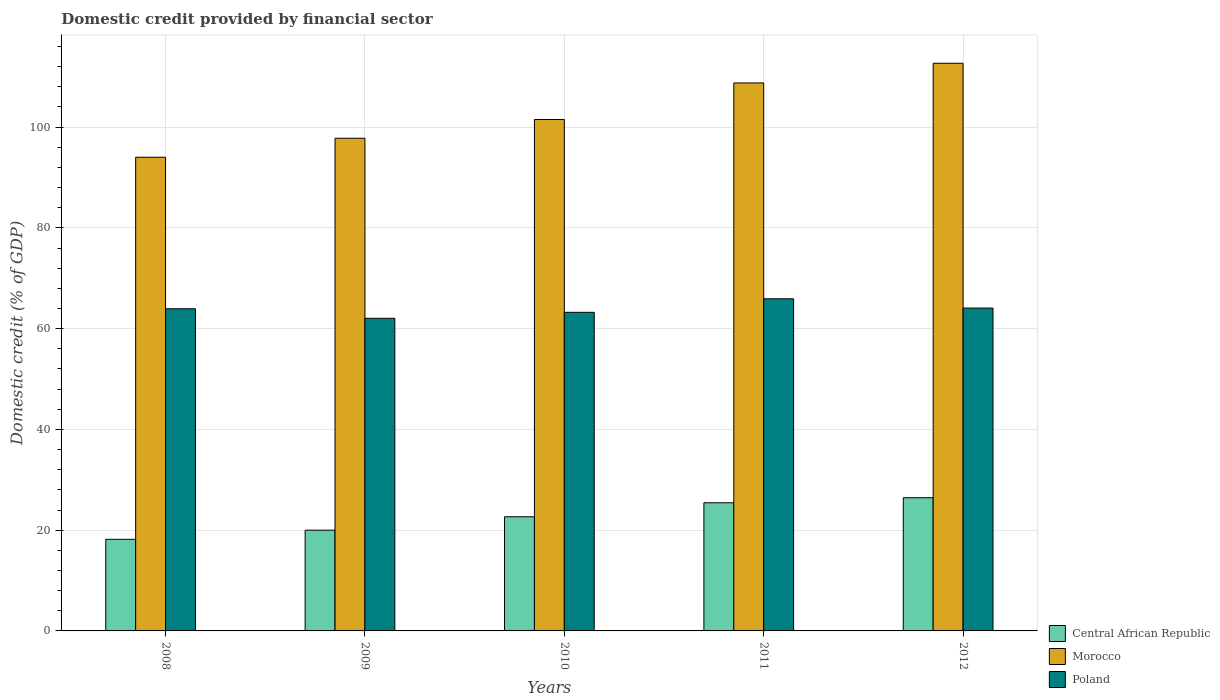Are the number of bars on each tick of the X-axis equal?
Provide a short and direct response. Yes. How many bars are there on the 1st tick from the left?
Offer a very short reply. 3. How many bars are there on the 3rd tick from the right?
Give a very brief answer. 3. What is the label of the 3rd group of bars from the left?
Provide a succinct answer. 2010. What is the domestic credit in Central African Republic in 2011?
Give a very brief answer. 25.44. Across all years, what is the maximum domestic credit in Poland?
Keep it short and to the point. 65.92. Across all years, what is the minimum domestic credit in Poland?
Ensure brevity in your answer.  62.05. In which year was the domestic credit in Morocco maximum?
Make the answer very short. 2012. In which year was the domestic credit in Morocco minimum?
Offer a terse response. 2008. What is the total domestic credit in Morocco in the graph?
Keep it short and to the point. 514.77. What is the difference between the domestic credit in Central African Republic in 2008 and that in 2011?
Offer a very short reply. -7.25. What is the difference between the domestic credit in Poland in 2011 and the domestic credit in Central African Republic in 2009?
Keep it short and to the point. 45.93. What is the average domestic credit in Morocco per year?
Provide a short and direct response. 102.95. In the year 2009, what is the difference between the domestic credit in Poland and domestic credit in Central African Republic?
Offer a very short reply. 42.05. What is the ratio of the domestic credit in Morocco in 2010 to that in 2011?
Keep it short and to the point. 0.93. Is the domestic credit in Morocco in 2008 less than that in 2011?
Ensure brevity in your answer.  Yes. Is the difference between the domestic credit in Poland in 2008 and 2011 greater than the difference between the domestic credit in Central African Republic in 2008 and 2011?
Your answer should be compact. Yes. What is the difference between the highest and the second highest domestic credit in Poland?
Give a very brief answer. 1.84. What is the difference between the highest and the lowest domestic credit in Morocco?
Your answer should be very brief. 18.65. In how many years, is the domestic credit in Poland greater than the average domestic credit in Poland taken over all years?
Your answer should be very brief. 3. What does the 1st bar from the left in 2012 represents?
Your response must be concise. Central African Republic. Is it the case that in every year, the sum of the domestic credit in Central African Republic and domestic credit in Morocco is greater than the domestic credit in Poland?
Ensure brevity in your answer.  Yes. How many bars are there?
Provide a succinct answer. 15. Are all the bars in the graph horizontal?
Make the answer very short. No. How many years are there in the graph?
Your answer should be very brief. 5. What is the difference between two consecutive major ticks on the Y-axis?
Your answer should be compact. 20. Are the values on the major ticks of Y-axis written in scientific E-notation?
Keep it short and to the point. No. Does the graph contain grids?
Your answer should be very brief. Yes. Where does the legend appear in the graph?
Ensure brevity in your answer.  Bottom right. How many legend labels are there?
Your answer should be very brief. 3. What is the title of the graph?
Your answer should be compact. Domestic credit provided by financial sector. What is the label or title of the X-axis?
Give a very brief answer. Years. What is the label or title of the Y-axis?
Keep it short and to the point. Domestic credit (% of GDP). What is the Domestic credit (% of GDP) in Central African Republic in 2008?
Your answer should be compact. 18.18. What is the Domestic credit (% of GDP) of Morocco in 2008?
Offer a terse response. 94.02. What is the Domestic credit (% of GDP) of Poland in 2008?
Your answer should be very brief. 63.95. What is the Domestic credit (% of GDP) in Central African Republic in 2009?
Make the answer very short. 20. What is the Domestic credit (% of GDP) of Morocco in 2009?
Give a very brief answer. 97.79. What is the Domestic credit (% of GDP) of Poland in 2009?
Provide a short and direct response. 62.05. What is the Domestic credit (% of GDP) in Central African Republic in 2010?
Give a very brief answer. 22.66. What is the Domestic credit (% of GDP) in Morocco in 2010?
Keep it short and to the point. 101.51. What is the Domestic credit (% of GDP) of Poland in 2010?
Keep it short and to the point. 63.24. What is the Domestic credit (% of GDP) in Central African Republic in 2011?
Offer a terse response. 25.44. What is the Domestic credit (% of GDP) in Morocco in 2011?
Provide a short and direct response. 108.77. What is the Domestic credit (% of GDP) in Poland in 2011?
Your response must be concise. 65.92. What is the Domestic credit (% of GDP) of Central African Republic in 2012?
Make the answer very short. 26.44. What is the Domestic credit (% of GDP) of Morocco in 2012?
Your response must be concise. 112.68. What is the Domestic credit (% of GDP) of Poland in 2012?
Ensure brevity in your answer.  64.08. Across all years, what is the maximum Domestic credit (% of GDP) in Central African Republic?
Make the answer very short. 26.44. Across all years, what is the maximum Domestic credit (% of GDP) of Morocco?
Ensure brevity in your answer.  112.68. Across all years, what is the maximum Domestic credit (% of GDP) of Poland?
Offer a very short reply. 65.92. Across all years, what is the minimum Domestic credit (% of GDP) in Central African Republic?
Keep it short and to the point. 18.18. Across all years, what is the minimum Domestic credit (% of GDP) in Morocco?
Your answer should be very brief. 94.02. Across all years, what is the minimum Domestic credit (% of GDP) in Poland?
Give a very brief answer. 62.05. What is the total Domestic credit (% of GDP) of Central African Republic in the graph?
Offer a terse response. 112.72. What is the total Domestic credit (% of GDP) in Morocco in the graph?
Provide a succinct answer. 514.77. What is the total Domestic credit (% of GDP) of Poland in the graph?
Provide a succinct answer. 319.25. What is the difference between the Domestic credit (% of GDP) in Central African Republic in 2008 and that in 2009?
Offer a terse response. -1.81. What is the difference between the Domestic credit (% of GDP) in Morocco in 2008 and that in 2009?
Offer a terse response. -3.77. What is the difference between the Domestic credit (% of GDP) of Poland in 2008 and that in 2009?
Offer a very short reply. 1.89. What is the difference between the Domestic credit (% of GDP) in Central African Republic in 2008 and that in 2010?
Provide a short and direct response. -4.47. What is the difference between the Domestic credit (% of GDP) of Morocco in 2008 and that in 2010?
Provide a succinct answer. -7.49. What is the difference between the Domestic credit (% of GDP) of Poland in 2008 and that in 2010?
Your answer should be compact. 0.7. What is the difference between the Domestic credit (% of GDP) in Central African Republic in 2008 and that in 2011?
Offer a very short reply. -7.25. What is the difference between the Domestic credit (% of GDP) of Morocco in 2008 and that in 2011?
Your answer should be very brief. -14.74. What is the difference between the Domestic credit (% of GDP) of Poland in 2008 and that in 2011?
Make the answer very short. -1.98. What is the difference between the Domestic credit (% of GDP) in Central African Republic in 2008 and that in 2012?
Your response must be concise. -8.25. What is the difference between the Domestic credit (% of GDP) of Morocco in 2008 and that in 2012?
Keep it short and to the point. -18.65. What is the difference between the Domestic credit (% of GDP) in Poland in 2008 and that in 2012?
Provide a succinct answer. -0.14. What is the difference between the Domestic credit (% of GDP) in Central African Republic in 2009 and that in 2010?
Your answer should be very brief. -2.66. What is the difference between the Domestic credit (% of GDP) in Morocco in 2009 and that in 2010?
Keep it short and to the point. -3.72. What is the difference between the Domestic credit (% of GDP) of Poland in 2009 and that in 2010?
Offer a terse response. -1.19. What is the difference between the Domestic credit (% of GDP) in Central African Republic in 2009 and that in 2011?
Make the answer very short. -5.44. What is the difference between the Domestic credit (% of GDP) in Morocco in 2009 and that in 2011?
Keep it short and to the point. -10.97. What is the difference between the Domestic credit (% of GDP) in Poland in 2009 and that in 2011?
Provide a succinct answer. -3.87. What is the difference between the Domestic credit (% of GDP) in Central African Republic in 2009 and that in 2012?
Offer a very short reply. -6.44. What is the difference between the Domestic credit (% of GDP) of Morocco in 2009 and that in 2012?
Your answer should be compact. -14.89. What is the difference between the Domestic credit (% of GDP) in Poland in 2009 and that in 2012?
Ensure brevity in your answer.  -2.03. What is the difference between the Domestic credit (% of GDP) of Central African Republic in 2010 and that in 2011?
Keep it short and to the point. -2.78. What is the difference between the Domestic credit (% of GDP) in Morocco in 2010 and that in 2011?
Your response must be concise. -7.26. What is the difference between the Domestic credit (% of GDP) in Poland in 2010 and that in 2011?
Offer a very short reply. -2.68. What is the difference between the Domestic credit (% of GDP) of Central African Republic in 2010 and that in 2012?
Make the answer very short. -3.78. What is the difference between the Domestic credit (% of GDP) in Morocco in 2010 and that in 2012?
Keep it short and to the point. -11.17. What is the difference between the Domestic credit (% of GDP) in Poland in 2010 and that in 2012?
Offer a terse response. -0.84. What is the difference between the Domestic credit (% of GDP) in Central African Republic in 2011 and that in 2012?
Offer a terse response. -1. What is the difference between the Domestic credit (% of GDP) in Morocco in 2011 and that in 2012?
Your answer should be compact. -3.91. What is the difference between the Domestic credit (% of GDP) of Poland in 2011 and that in 2012?
Provide a short and direct response. 1.84. What is the difference between the Domestic credit (% of GDP) in Central African Republic in 2008 and the Domestic credit (% of GDP) in Morocco in 2009?
Provide a succinct answer. -79.61. What is the difference between the Domestic credit (% of GDP) of Central African Republic in 2008 and the Domestic credit (% of GDP) of Poland in 2009?
Give a very brief answer. -43.87. What is the difference between the Domestic credit (% of GDP) of Morocco in 2008 and the Domestic credit (% of GDP) of Poland in 2009?
Your answer should be very brief. 31.97. What is the difference between the Domestic credit (% of GDP) in Central African Republic in 2008 and the Domestic credit (% of GDP) in Morocco in 2010?
Offer a very short reply. -83.32. What is the difference between the Domestic credit (% of GDP) of Central African Republic in 2008 and the Domestic credit (% of GDP) of Poland in 2010?
Ensure brevity in your answer.  -45.06. What is the difference between the Domestic credit (% of GDP) in Morocco in 2008 and the Domestic credit (% of GDP) in Poland in 2010?
Your response must be concise. 30.78. What is the difference between the Domestic credit (% of GDP) in Central African Republic in 2008 and the Domestic credit (% of GDP) in Morocco in 2011?
Keep it short and to the point. -90.58. What is the difference between the Domestic credit (% of GDP) in Central African Republic in 2008 and the Domestic credit (% of GDP) in Poland in 2011?
Provide a succinct answer. -47.74. What is the difference between the Domestic credit (% of GDP) of Morocco in 2008 and the Domestic credit (% of GDP) of Poland in 2011?
Offer a very short reply. 28.1. What is the difference between the Domestic credit (% of GDP) of Central African Republic in 2008 and the Domestic credit (% of GDP) of Morocco in 2012?
Offer a terse response. -94.49. What is the difference between the Domestic credit (% of GDP) in Central African Republic in 2008 and the Domestic credit (% of GDP) in Poland in 2012?
Your answer should be very brief. -45.9. What is the difference between the Domestic credit (% of GDP) of Morocco in 2008 and the Domestic credit (% of GDP) of Poland in 2012?
Make the answer very short. 29.94. What is the difference between the Domestic credit (% of GDP) in Central African Republic in 2009 and the Domestic credit (% of GDP) in Morocco in 2010?
Your response must be concise. -81.51. What is the difference between the Domestic credit (% of GDP) of Central African Republic in 2009 and the Domestic credit (% of GDP) of Poland in 2010?
Provide a short and direct response. -43.24. What is the difference between the Domestic credit (% of GDP) of Morocco in 2009 and the Domestic credit (% of GDP) of Poland in 2010?
Offer a very short reply. 34.55. What is the difference between the Domestic credit (% of GDP) of Central African Republic in 2009 and the Domestic credit (% of GDP) of Morocco in 2011?
Keep it short and to the point. -88.77. What is the difference between the Domestic credit (% of GDP) in Central African Republic in 2009 and the Domestic credit (% of GDP) in Poland in 2011?
Give a very brief answer. -45.93. What is the difference between the Domestic credit (% of GDP) of Morocco in 2009 and the Domestic credit (% of GDP) of Poland in 2011?
Provide a succinct answer. 31.87. What is the difference between the Domestic credit (% of GDP) of Central African Republic in 2009 and the Domestic credit (% of GDP) of Morocco in 2012?
Ensure brevity in your answer.  -92.68. What is the difference between the Domestic credit (% of GDP) in Central African Republic in 2009 and the Domestic credit (% of GDP) in Poland in 2012?
Provide a succinct answer. -44.09. What is the difference between the Domestic credit (% of GDP) of Morocco in 2009 and the Domestic credit (% of GDP) of Poland in 2012?
Provide a short and direct response. 33.71. What is the difference between the Domestic credit (% of GDP) of Central African Republic in 2010 and the Domestic credit (% of GDP) of Morocco in 2011?
Offer a very short reply. -86.11. What is the difference between the Domestic credit (% of GDP) of Central African Republic in 2010 and the Domestic credit (% of GDP) of Poland in 2011?
Your answer should be compact. -43.27. What is the difference between the Domestic credit (% of GDP) in Morocco in 2010 and the Domestic credit (% of GDP) in Poland in 2011?
Provide a succinct answer. 35.58. What is the difference between the Domestic credit (% of GDP) of Central African Republic in 2010 and the Domestic credit (% of GDP) of Morocco in 2012?
Provide a succinct answer. -90.02. What is the difference between the Domestic credit (% of GDP) in Central African Republic in 2010 and the Domestic credit (% of GDP) in Poland in 2012?
Make the answer very short. -41.43. What is the difference between the Domestic credit (% of GDP) of Morocco in 2010 and the Domestic credit (% of GDP) of Poland in 2012?
Offer a terse response. 37.43. What is the difference between the Domestic credit (% of GDP) of Central African Republic in 2011 and the Domestic credit (% of GDP) of Morocco in 2012?
Offer a very short reply. -87.24. What is the difference between the Domestic credit (% of GDP) of Central African Republic in 2011 and the Domestic credit (% of GDP) of Poland in 2012?
Provide a succinct answer. -38.65. What is the difference between the Domestic credit (% of GDP) of Morocco in 2011 and the Domestic credit (% of GDP) of Poland in 2012?
Your answer should be very brief. 44.68. What is the average Domestic credit (% of GDP) in Central African Republic per year?
Keep it short and to the point. 22.54. What is the average Domestic credit (% of GDP) in Morocco per year?
Keep it short and to the point. 102.95. What is the average Domestic credit (% of GDP) of Poland per year?
Provide a succinct answer. 63.85. In the year 2008, what is the difference between the Domestic credit (% of GDP) in Central African Republic and Domestic credit (% of GDP) in Morocco?
Provide a succinct answer. -75.84. In the year 2008, what is the difference between the Domestic credit (% of GDP) of Central African Republic and Domestic credit (% of GDP) of Poland?
Offer a terse response. -45.76. In the year 2008, what is the difference between the Domestic credit (% of GDP) in Morocco and Domestic credit (% of GDP) in Poland?
Offer a terse response. 30.08. In the year 2009, what is the difference between the Domestic credit (% of GDP) in Central African Republic and Domestic credit (% of GDP) in Morocco?
Make the answer very short. -77.79. In the year 2009, what is the difference between the Domestic credit (% of GDP) of Central African Republic and Domestic credit (% of GDP) of Poland?
Provide a succinct answer. -42.05. In the year 2009, what is the difference between the Domestic credit (% of GDP) of Morocco and Domestic credit (% of GDP) of Poland?
Make the answer very short. 35.74. In the year 2010, what is the difference between the Domestic credit (% of GDP) of Central African Republic and Domestic credit (% of GDP) of Morocco?
Make the answer very short. -78.85. In the year 2010, what is the difference between the Domestic credit (% of GDP) in Central African Republic and Domestic credit (% of GDP) in Poland?
Make the answer very short. -40.58. In the year 2010, what is the difference between the Domestic credit (% of GDP) in Morocco and Domestic credit (% of GDP) in Poland?
Keep it short and to the point. 38.27. In the year 2011, what is the difference between the Domestic credit (% of GDP) in Central African Republic and Domestic credit (% of GDP) in Morocco?
Offer a terse response. -83.33. In the year 2011, what is the difference between the Domestic credit (% of GDP) in Central African Republic and Domestic credit (% of GDP) in Poland?
Your response must be concise. -40.49. In the year 2011, what is the difference between the Domestic credit (% of GDP) of Morocco and Domestic credit (% of GDP) of Poland?
Your answer should be compact. 42.84. In the year 2012, what is the difference between the Domestic credit (% of GDP) of Central African Republic and Domestic credit (% of GDP) of Morocco?
Your answer should be very brief. -86.24. In the year 2012, what is the difference between the Domestic credit (% of GDP) in Central African Republic and Domestic credit (% of GDP) in Poland?
Your response must be concise. -37.65. In the year 2012, what is the difference between the Domestic credit (% of GDP) in Morocco and Domestic credit (% of GDP) in Poland?
Give a very brief answer. 48.59. What is the ratio of the Domestic credit (% of GDP) in Central African Republic in 2008 to that in 2009?
Offer a terse response. 0.91. What is the ratio of the Domestic credit (% of GDP) of Morocco in 2008 to that in 2009?
Your answer should be very brief. 0.96. What is the ratio of the Domestic credit (% of GDP) of Poland in 2008 to that in 2009?
Give a very brief answer. 1.03. What is the ratio of the Domestic credit (% of GDP) of Central African Republic in 2008 to that in 2010?
Your answer should be very brief. 0.8. What is the ratio of the Domestic credit (% of GDP) of Morocco in 2008 to that in 2010?
Provide a short and direct response. 0.93. What is the ratio of the Domestic credit (% of GDP) in Poland in 2008 to that in 2010?
Your answer should be very brief. 1.01. What is the ratio of the Domestic credit (% of GDP) in Central African Republic in 2008 to that in 2011?
Ensure brevity in your answer.  0.71. What is the ratio of the Domestic credit (% of GDP) in Morocco in 2008 to that in 2011?
Ensure brevity in your answer.  0.86. What is the ratio of the Domestic credit (% of GDP) in Poland in 2008 to that in 2011?
Offer a terse response. 0.97. What is the ratio of the Domestic credit (% of GDP) of Central African Republic in 2008 to that in 2012?
Provide a short and direct response. 0.69. What is the ratio of the Domestic credit (% of GDP) of Morocco in 2008 to that in 2012?
Your answer should be compact. 0.83. What is the ratio of the Domestic credit (% of GDP) in Central African Republic in 2009 to that in 2010?
Provide a succinct answer. 0.88. What is the ratio of the Domestic credit (% of GDP) in Morocco in 2009 to that in 2010?
Your answer should be very brief. 0.96. What is the ratio of the Domestic credit (% of GDP) of Poland in 2009 to that in 2010?
Keep it short and to the point. 0.98. What is the ratio of the Domestic credit (% of GDP) of Central African Republic in 2009 to that in 2011?
Make the answer very short. 0.79. What is the ratio of the Domestic credit (% of GDP) in Morocco in 2009 to that in 2011?
Offer a very short reply. 0.9. What is the ratio of the Domestic credit (% of GDP) of Poland in 2009 to that in 2011?
Give a very brief answer. 0.94. What is the ratio of the Domestic credit (% of GDP) of Central African Republic in 2009 to that in 2012?
Ensure brevity in your answer.  0.76. What is the ratio of the Domestic credit (% of GDP) of Morocco in 2009 to that in 2012?
Your answer should be very brief. 0.87. What is the ratio of the Domestic credit (% of GDP) of Poland in 2009 to that in 2012?
Your answer should be compact. 0.97. What is the ratio of the Domestic credit (% of GDP) of Central African Republic in 2010 to that in 2011?
Your response must be concise. 0.89. What is the ratio of the Domestic credit (% of GDP) in Morocco in 2010 to that in 2011?
Provide a short and direct response. 0.93. What is the ratio of the Domestic credit (% of GDP) of Poland in 2010 to that in 2011?
Give a very brief answer. 0.96. What is the ratio of the Domestic credit (% of GDP) of Central African Republic in 2010 to that in 2012?
Keep it short and to the point. 0.86. What is the ratio of the Domestic credit (% of GDP) in Morocco in 2010 to that in 2012?
Your response must be concise. 0.9. What is the ratio of the Domestic credit (% of GDP) in Central African Republic in 2011 to that in 2012?
Offer a very short reply. 0.96. What is the ratio of the Domestic credit (% of GDP) of Morocco in 2011 to that in 2012?
Offer a very short reply. 0.97. What is the ratio of the Domestic credit (% of GDP) of Poland in 2011 to that in 2012?
Your answer should be compact. 1.03. What is the difference between the highest and the second highest Domestic credit (% of GDP) of Central African Republic?
Your answer should be very brief. 1. What is the difference between the highest and the second highest Domestic credit (% of GDP) of Morocco?
Provide a succinct answer. 3.91. What is the difference between the highest and the second highest Domestic credit (% of GDP) in Poland?
Give a very brief answer. 1.84. What is the difference between the highest and the lowest Domestic credit (% of GDP) in Central African Republic?
Your answer should be compact. 8.25. What is the difference between the highest and the lowest Domestic credit (% of GDP) of Morocco?
Your answer should be very brief. 18.65. What is the difference between the highest and the lowest Domestic credit (% of GDP) of Poland?
Your answer should be compact. 3.87. 